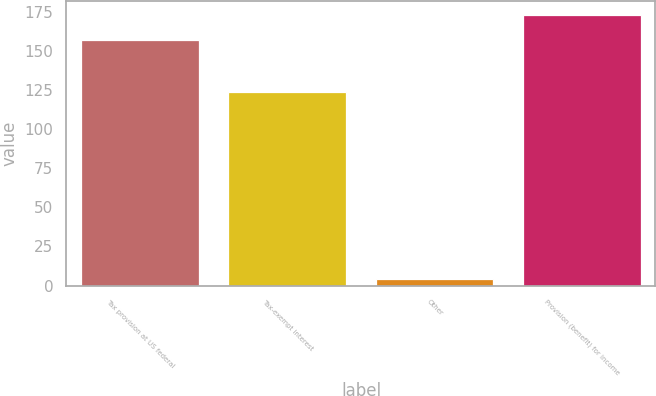Convert chart to OTSL. <chart><loc_0><loc_0><loc_500><loc_500><bar_chart><fcel>Tax provision at US federal<fcel>Tax-exempt interest<fcel>Other<fcel>Provision (benefit) for income<nl><fcel>157<fcel>124<fcel>4<fcel>173.2<nl></chart> 